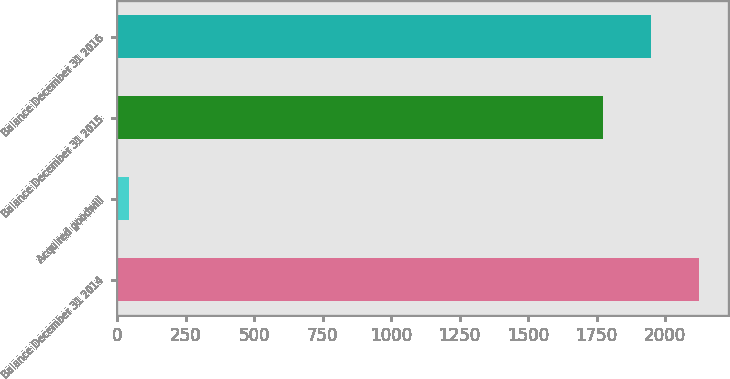<chart> <loc_0><loc_0><loc_500><loc_500><bar_chart><fcel>Balance December 31 2014<fcel>Acquired goodwill<fcel>Balance December 31 2015<fcel>Balance December 31 2016<nl><fcel>2122.6<fcel>42<fcel>1772<fcel>1947.3<nl></chart> 